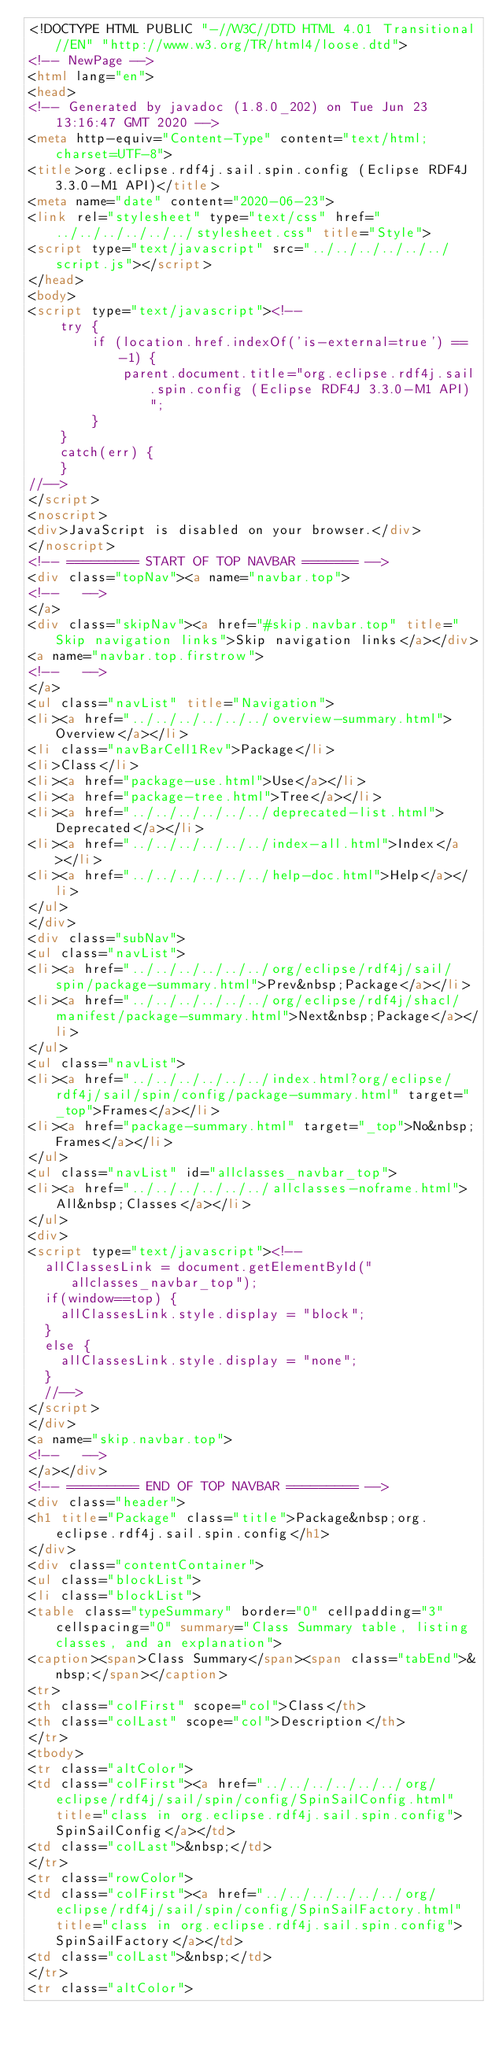<code> <loc_0><loc_0><loc_500><loc_500><_HTML_><!DOCTYPE HTML PUBLIC "-//W3C//DTD HTML 4.01 Transitional//EN" "http://www.w3.org/TR/html4/loose.dtd">
<!-- NewPage -->
<html lang="en">
<head>
<!-- Generated by javadoc (1.8.0_202) on Tue Jun 23 13:16:47 GMT 2020 -->
<meta http-equiv="Content-Type" content="text/html; charset=UTF-8">
<title>org.eclipse.rdf4j.sail.spin.config (Eclipse RDF4J 3.3.0-M1 API)</title>
<meta name="date" content="2020-06-23">
<link rel="stylesheet" type="text/css" href="../../../../../../stylesheet.css" title="Style">
<script type="text/javascript" src="../../../../../../script.js"></script>
</head>
<body>
<script type="text/javascript"><!--
    try {
        if (location.href.indexOf('is-external=true') == -1) {
            parent.document.title="org.eclipse.rdf4j.sail.spin.config (Eclipse RDF4J 3.3.0-M1 API)";
        }
    }
    catch(err) {
    }
//-->
</script>
<noscript>
<div>JavaScript is disabled on your browser.</div>
</noscript>
<!-- ========= START OF TOP NAVBAR ======= -->
<div class="topNav"><a name="navbar.top">
<!--   -->
</a>
<div class="skipNav"><a href="#skip.navbar.top" title="Skip navigation links">Skip navigation links</a></div>
<a name="navbar.top.firstrow">
<!--   -->
</a>
<ul class="navList" title="Navigation">
<li><a href="../../../../../../overview-summary.html">Overview</a></li>
<li class="navBarCell1Rev">Package</li>
<li>Class</li>
<li><a href="package-use.html">Use</a></li>
<li><a href="package-tree.html">Tree</a></li>
<li><a href="../../../../../../deprecated-list.html">Deprecated</a></li>
<li><a href="../../../../../../index-all.html">Index</a></li>
<li><a href="../../../../../../help-doc.html">Help</a></li>
</ul>
</div>
<div class="subNav">
<ul class="navList">
<li><a href="../../../../../../org/eclipse/rdf4j/sail/spin/package-summary.html">Prev&nbsp;Package</a></li>
<li><a href="../../../../../../org/eclipse/rdf4j/shacl/manifest/package-summary.html">Next&nbsp;Package</a></li>
</ul>
<ul class="navList">
<li><a href="../../../../../../index.html?org/eclipse/rdf4j/sail/spin/config/package-summary.html" target="_top">Frames</a></li>
<li><a href="package-summary.html" target="_top">No&nbsp;Frames</a></li>
</ul>
<ul class="navList" id="allclasses_navbar_top">
<li><a href="../../../../../../allclasses-noframe.html">All&nbsp;Classes</a></li>
</ul>
<div>
<script type="text/javascript"><!--
  allClassesLink = document.getElementById("allclasses_navbar_top");
  if(window==top) {
    allClassesLink.style.display = "block";
  }
  else {
    allClassesLink.style.display = "none";
  }
  //-->
</script>
</div>
<a name="skip.navbar.top">
<!--   -->
</a></div>
<!-- ========= END OF TOP NAVBAR ========= -->
<div class="header">
<h1 title="Package" class="title">Package&nbsp;org.eclipse.rdf4j.sail.spin.config</h1>
</div>
<div class="contentContainer">
<ul class="blockList">
<li class="blockList">
<table class="typeSummary" border="0" cellpadding="3" cellspacing="0" summary="Class Summary table, listing classes, and an explanation">
<caption><span>Class Summary</span><span class="tabEnd">&nbsp;</span></caption>
<tr>
<th class="colFirst" scope="col">Class</th>
<th class="colLast" scope="col">Description</th>
</tr>
<tbody>
<tr class="altColor">
<td class="colFirst"><a href="../../../../../../org/eclipse/rdf4j/sail/spin/config/SpinSailConfig.html" title="class in org.eclipse.rdf4j.sail.spin.config">SpinSailConfig</a></td>
<td class="colLast">&nbsp;</td>
</tr>
<tr class="rowColor">
<td class="colFirst"><a href="../../../../../../org/eclipse/rdf4j/sail/spin/config/SpinSailFactory.html" title="class in org.eclipse.rdf4j.sail.spin.config">SpinSailFactory</a></td>
<td class="colLast">&nbsp;</td>
</tr>
<tr class="altColor"></code> 